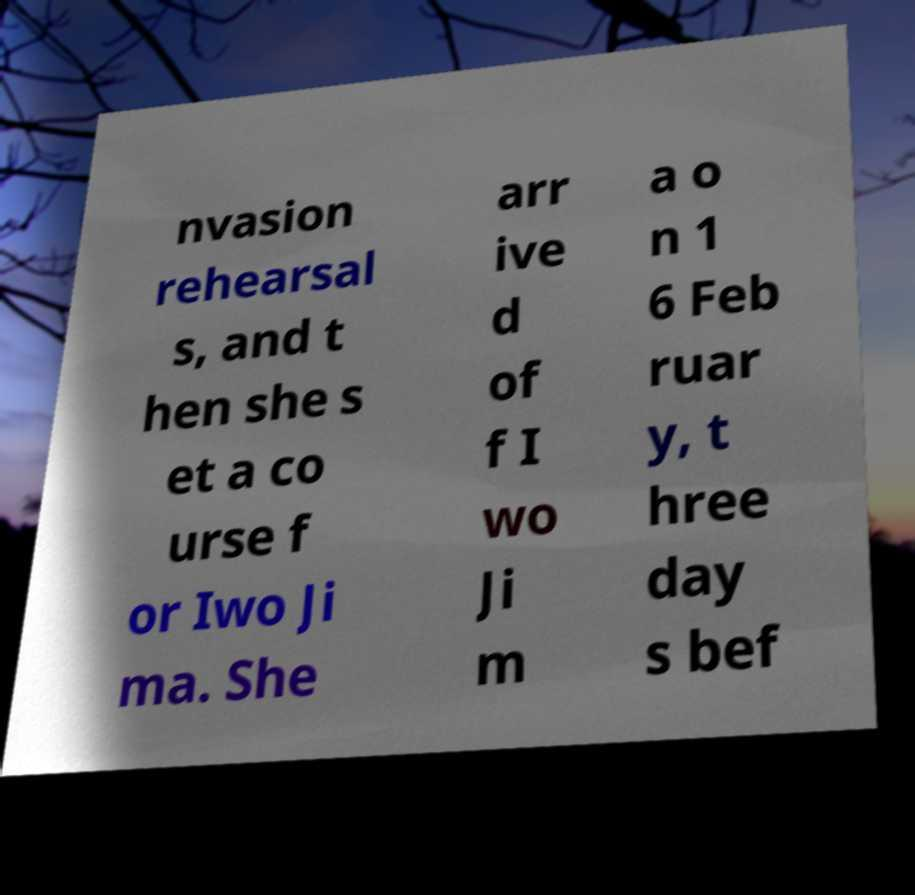Could you extract and type out the text from this image? nvasion rehearsal s, and t hen she s et a co urse f or Iwo Ji ma. She arr ive d of f I wo Ji m a o n 1 6 Feb ruar y, t hree day s bef 